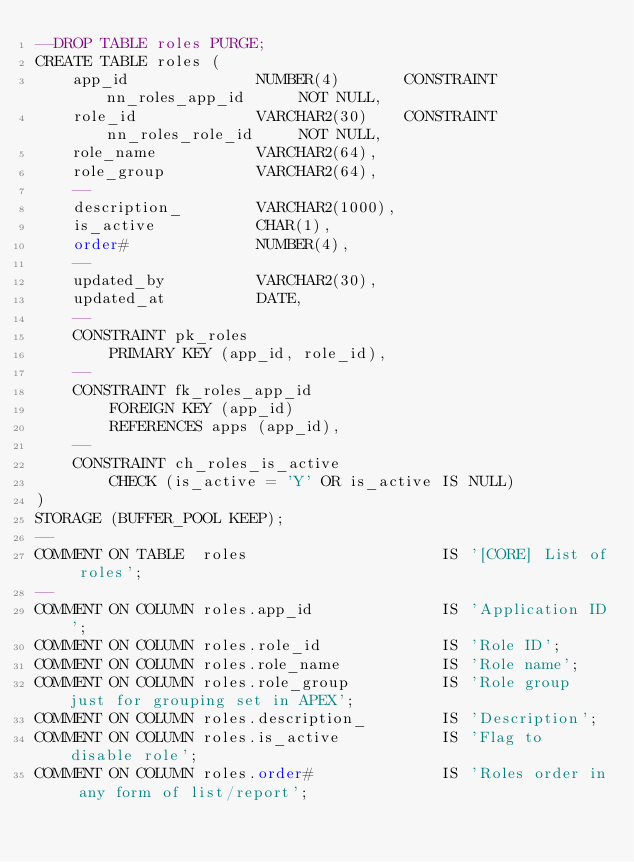Convert code to text. <code><loc_0><loc_0><loc_500><loc_500><_SQL_>--DROP TABLE roles PURGE;
CREATE TABLE roles (
    app_id              NUMBER(4)       CONSTRAINT nn_roles_app_id      NOT NULL,
    role_id             VARCHAR2(30)    CONSTRAINT nn_roles_role_id     NOT NULL,
    role_name           VARCHAR2(64),
    role_group          VARCHAR2(64),
    --
    description_        VARCHAR2(1000),
    is_active           CHAR(1),
    order#              NUMBER(4),
    --
    updated_by          VARCHAR2(30),
    updated_at          DATE,
    --
    CONSTRAINT pk_roles
        PRIMARY KEY (app_id, role_id),
    --
    CONSTRAINT fk_roles_app_id
        FOREIGN KEY (app_id)
        REFERENCES apps (app_id),
    --
    CONSTRAINT ch_roles_is_active
        CHECK (is_active = 'Y' OR is_active IS NULL)
)
STORAGE (BUFFER_POOL KEEP);
--
COMMENT ON TABLE  roles                     IS '[CORE] List of roles';
--
COMMENT ON COLUMN roles.app_id              IS 'Application ID';
COMMENT ON COLUMN roles.role_id             IS 'Role ID';
COMMENT ON COLUMN roles.role_name           IS 'Role name';
COMMENT ON COLUMN roles.role_group          IS 'Role group just for grouping set in APEX';
COMMENT ON COLUMN roles.description_        IS 'Description';
COMMENT ON COLUMN roles.is_active           IS 'Flag to disable role';
COMMENT ON COLUMN roles.order#              IS 'Roles order in any form of list/report';

</code> 